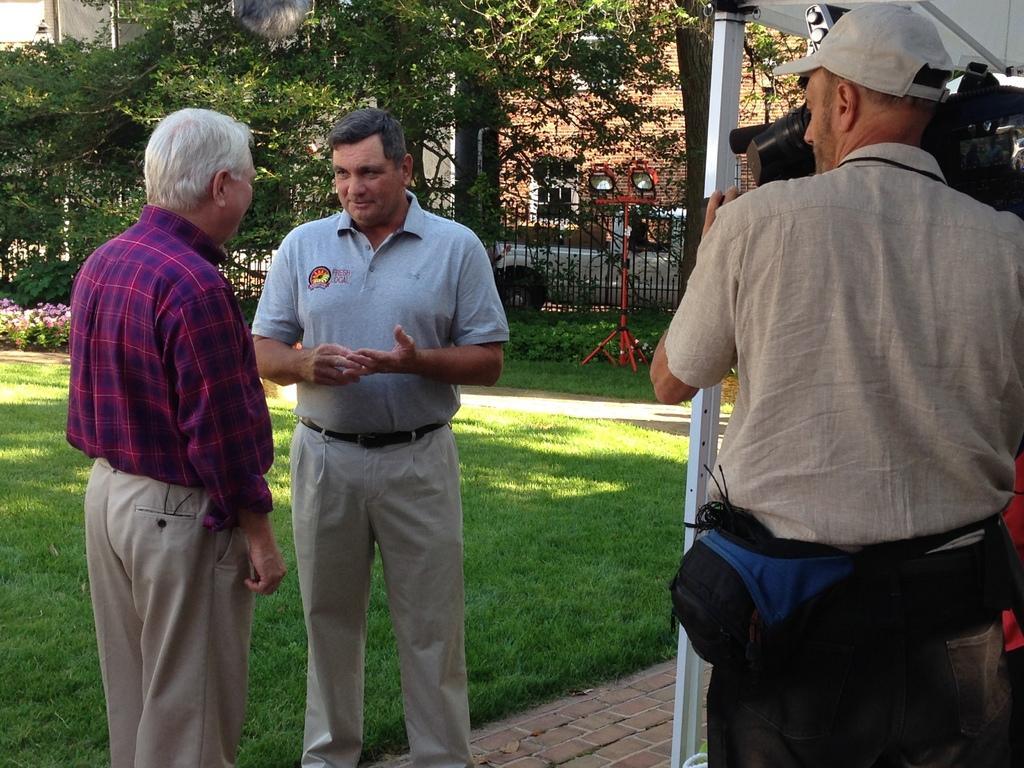Please provide a concise description of this image. This image is taken outdoors. At the bottom of the image there is a floor and a ground with grass on it. In the middle of the image two men are standing on the floor and talking. On the right side of the image a man is standing and he is holding a camera in his hands and there is a tent. In the background there is a building, a railing and there are a few trees. 